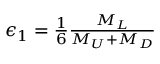<formula> <loc_0><loc_0><loc_500><loc_500>\begin{array} { r } { \epsilon _ { 1 } = \frac { 1 } { 6 } \frac { M _ { L } } { M _ { U } + M _ { D } } } \end{array}</formula> 